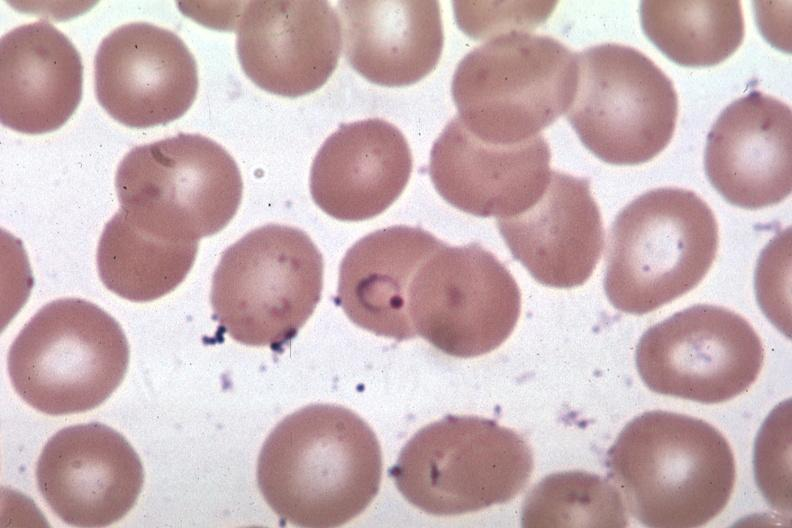what does this image show?
Answer the question using a single word or phrase. Oil wrights excellent ring form 